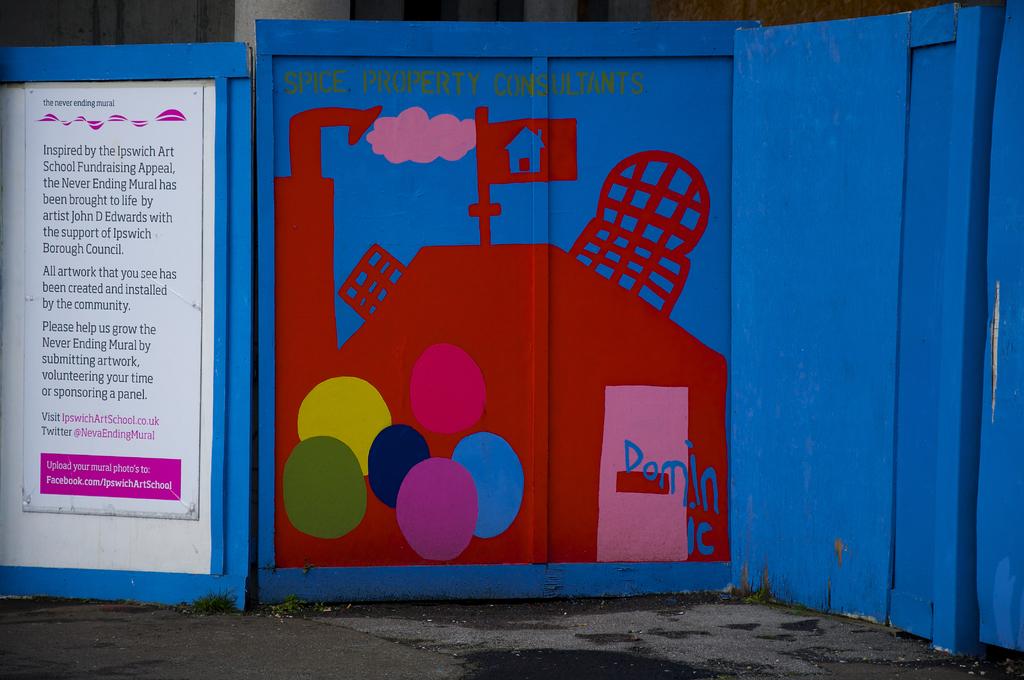What is this inspired by?
Provide a short and direct response. Ipswich art school fundraising appeal. 